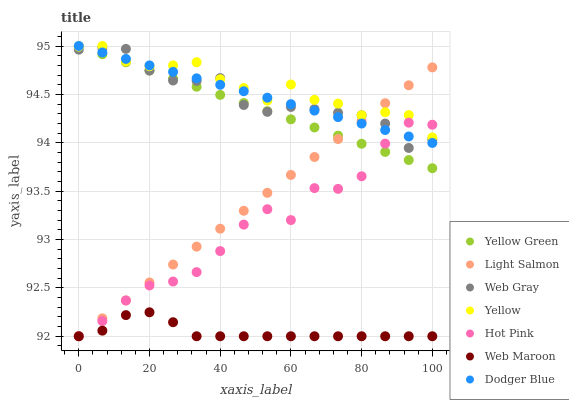Does Web Maroon have the minimum area under the curve?
Answer yes or no. Yes. Does Yellow have the maximum area under the curve?
Answer yes or no. Yes. Does Web Gray have the minimum area under the curve?
Answer yes or no. No. Does Web Gray have the maximum area under the curve?
Answer yes or no. No. Is Yellow Green the smoothest?
Answer yes or no. Yes. Is Hot Pink the roughest?
Answer yes or no. Yes. Is Web Gray the smoothest?
Answer yes or no. No. Is Web Gray the roughest?
Answer yes or no. No. Does Light Salmon have the lowest value?
Answer yes or no. Yes. Does Web Gray have the lowest value?
Answer yes or no. No. Does Dodger Blue have the highest value?
Answer yes or no. Yes. Does Web Gray have the highest value?
Answer yes or no. No. Is Web Maroon less than Yellow Green?
Answer yes or no. Yes. Is Yellow Green greater than Web Maroon?
Answer yes or no. Yes. Does Yellow Green intersect Dodger Blue?
Answer yes or no. Yes. Is Yellow Green less than Dodger Blue?
Answer yes or no. No. Is Yellow Green greater than Dodger Blue?
Answer yes or no. No. Does Web Maroon intersect Yellow Green?
Answer yes or no. No. 